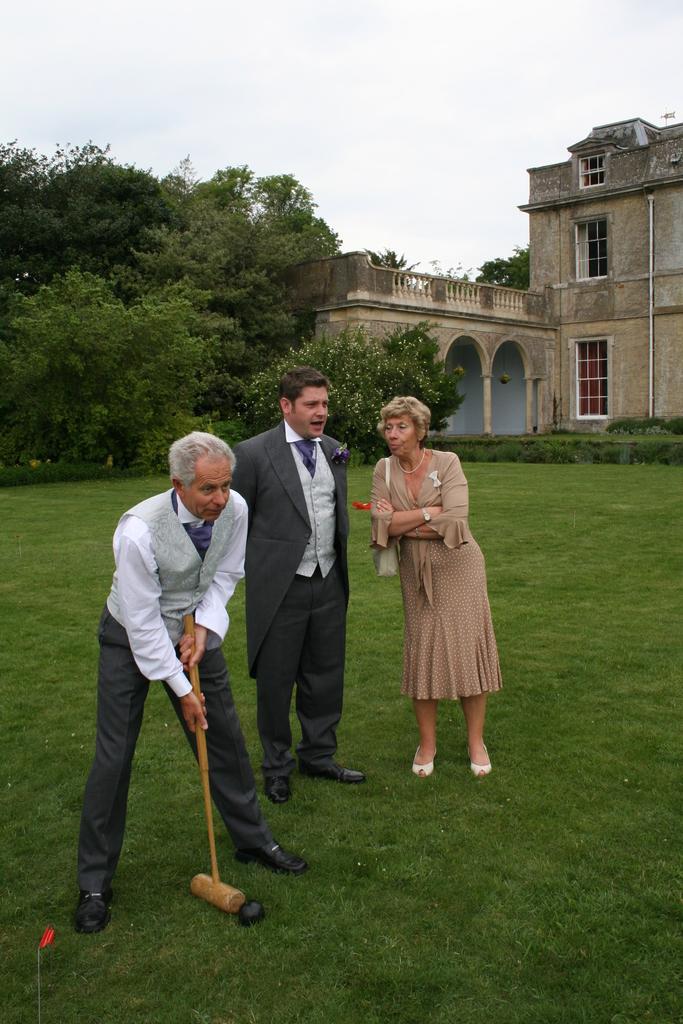How would you summarize this image in a sentence or two? In this image there are people standing on the grassland. Left side there is a person holding a hammer. There is a ball on the land. There is a person wearing a blazer and tie. Right side there is a woman carrying a bag. Right side there is a building. Background there are trees. Top of the image there is sky. 